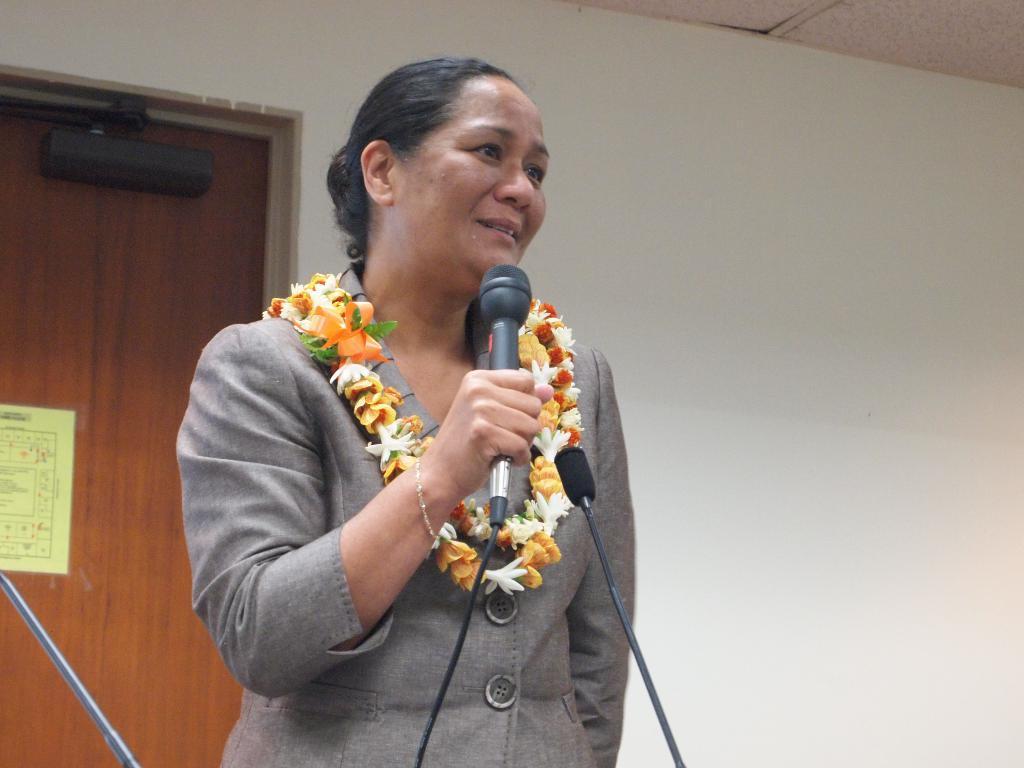Can you describe this image briefly? In this picture, we can see a person with garland, holding microphone, and we can see a few microphones at bottom side of the picture, and we can see the wall with door, poster with text, and the roof. 